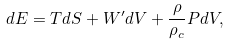<formula> <loc_0><loc_0><loc_500><loc_500>d E = T d S + W ^ { \prime } d V + \frac { \rho } { \rho _ { c } } P d V ,</formula> 